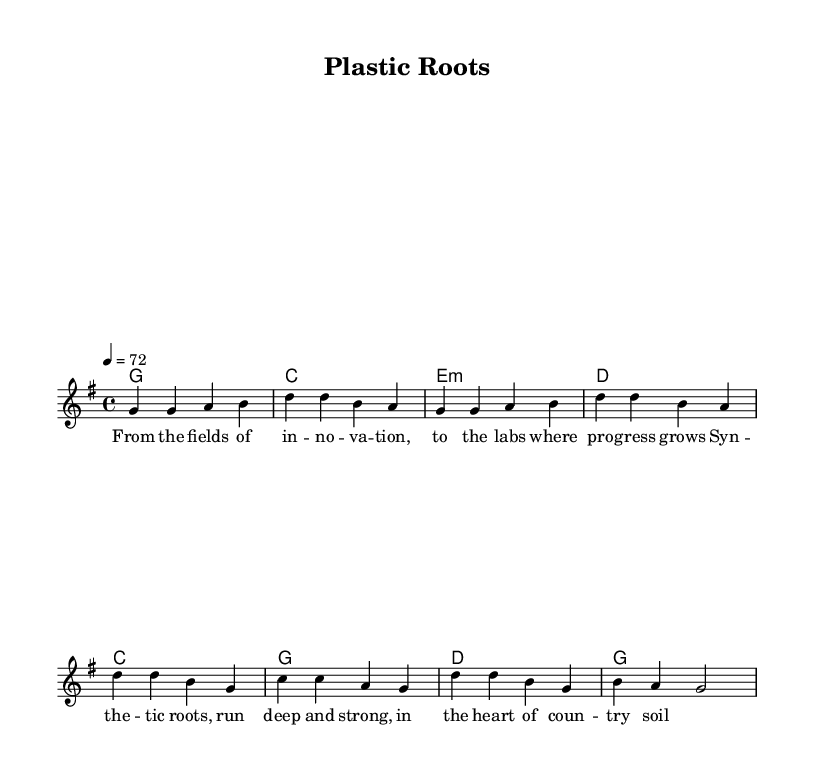What is the key signature of this music? The key signature is G major, which has one sharp (F#). This can be identified by looking at the beginning of the music sheet where the sharp is indicated.
Answer: G major What is the time signature of this music? The time signature is 4/4, which is visible in the notation after the clef indication. It shows that there are four beats per measure and that the quarter note gets one beat.
Answer: 4/4 What is the tempo of this piece? The tempo is indicated as 4 = 72, meaning that the quarter note is to be played at a speed of 72 beats per minute. This tempo is shown above the staff at the beginning of the music.
Answer: 72 How many measures are in the verse? The verse consists of 4 measures as indicated by the notation; each group of notes is separated by vertical lines which signal the end of a measure.
Answer: 4 What is the first chord in the chorus? The first chord in the chorus is C major, which is identified by looking at the chord symbols listed above the melody notes in the chorus section.
Answer: C Why is this song categorized as Country Rock? The song is categorized as Country Rock primarily because it features a blend of traditional country music elements, such as storytelling lyrics related to rural life, and rock music structures, as indicated by the chord progressions and rhythmic feel typical of the genre.
Answer: Storytelling lyrics and rock structures 